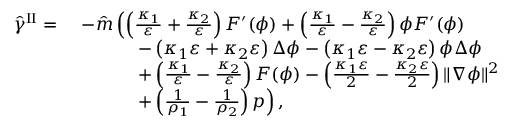Convert formula to latex. <formula><loc_0><loc_0><loc_500><loc_500>\begin{array} { r l } { \hat { \gamma } ^ { I I } = } & { - \hat { m } \left ( \left ( \frac { \kappa _ { 1 } } { \varepsilon } + \frac { \kappa _ { 2 } } { \varepsilon } \right ) F ^ { \prime } ( \phi ) + \left ( \frac { \kappa _ { 1 } } { \varepsilon } - \frac { \kappa _ { 2 } } { \varepsilon } \right ) \phi F ^ { \prime } ( \phi ) } \\ & { \quad - \left ( \kappa _ { 1 } \varepsilon + \kappa _ { 2 } \varepsilon \right ) \Delta \phi - \left ( \kappa _ { 1 } \varepsilon - \kappa _ { 2 } \varepsilon \right ) \phi \Delta \phi } \\ & { \quad + \left ( \frac { \kappa _ { 1 } } { \varepsilon } - \frac { \kappa _ { 2 } } { \varepsilon } \right ) F ( \phi ) - \left ( \frac { \kappa _ { 1 } \varepsilon } { 2 } - \frac { \kappa _ { 2 } \varepsilon } { 2 } \right ) \| \nabla \phi \| ^ { 2 } } \\ & { \quad + \left ( \frac { 1 } { \rho _ { 1 } } - \frac { 1 } { \rho _ { 2 } } \right ) p \right ) , } \end{array}</formula> 